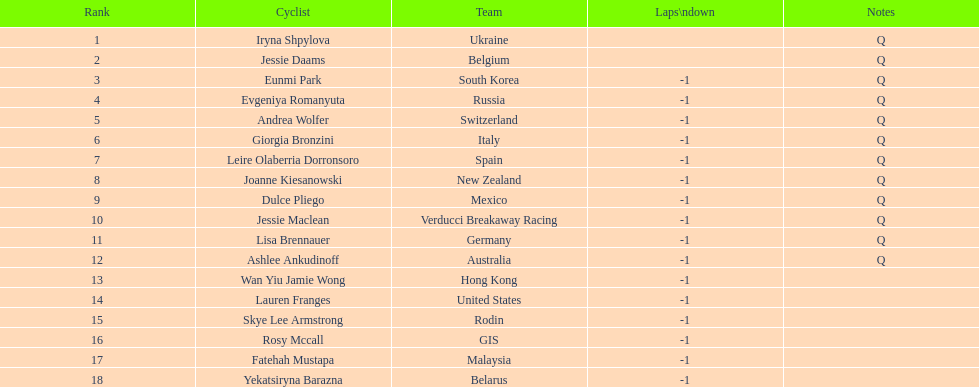What is belgium's numerical ranking? 2. Could you parse the entire table as a dict? {'header': ['Rank', 'Cyclist', 'Team', 'Laps\\ndown', 'Notes'], 'rows': [['1', 'Iryna Shpylova', 'Ukraine', '', 'Q'], ['2', 'Jessie Daams', 'Belgium', '', 'Q'], ['3', 'Eunmi Park', 'South Korea', '-1', 'Q'], ['4', 'Evgeniya Romanyuta', 'Russia', '-1', 'Q'], ['5', 'Andrea Wolfer', 'Switzerland', '-1', 'Q'], ['6', 'Giorgia Bronzini', 'Italy', '-1', 'Q'], ['7', 'Leire Olaberria Dorronsoro', 'Spain', '-1', 'Q'], ['8', 'Joanne Kiesanowski', 'New Zealand', '-1', 'Q'], ['9', 'Dulce Pliego', 'Mexico', '-1', 'Q'], ['10', 'Jessie Maclean', 'Verducci Breakaway Racing', '-1', 'Q'], ['11', 'Lisa Brennauer', 'Germany', '-1', 'Q'], ['12', 'Ashlee Ankudinoff', 'Australia', '-1', 'Q'], ['13', 'Wan Yiu Jamie Wong', 'Hong Kong', '-1', ''], ['14', 'Lauren Franges', 'United States', '-1', ''], ['15', 'Skye Lee Armstrong', 'Rodin', '-1', ''], ['16', 'Rosy Mccall', 'GIS', '-1', ''], ['17', 'Fatehah Mustapa', 'Malaysia', '-1', ''], ['18', 'Yekatsiryna Barazna', 'Belarus', '-1', '']]} 